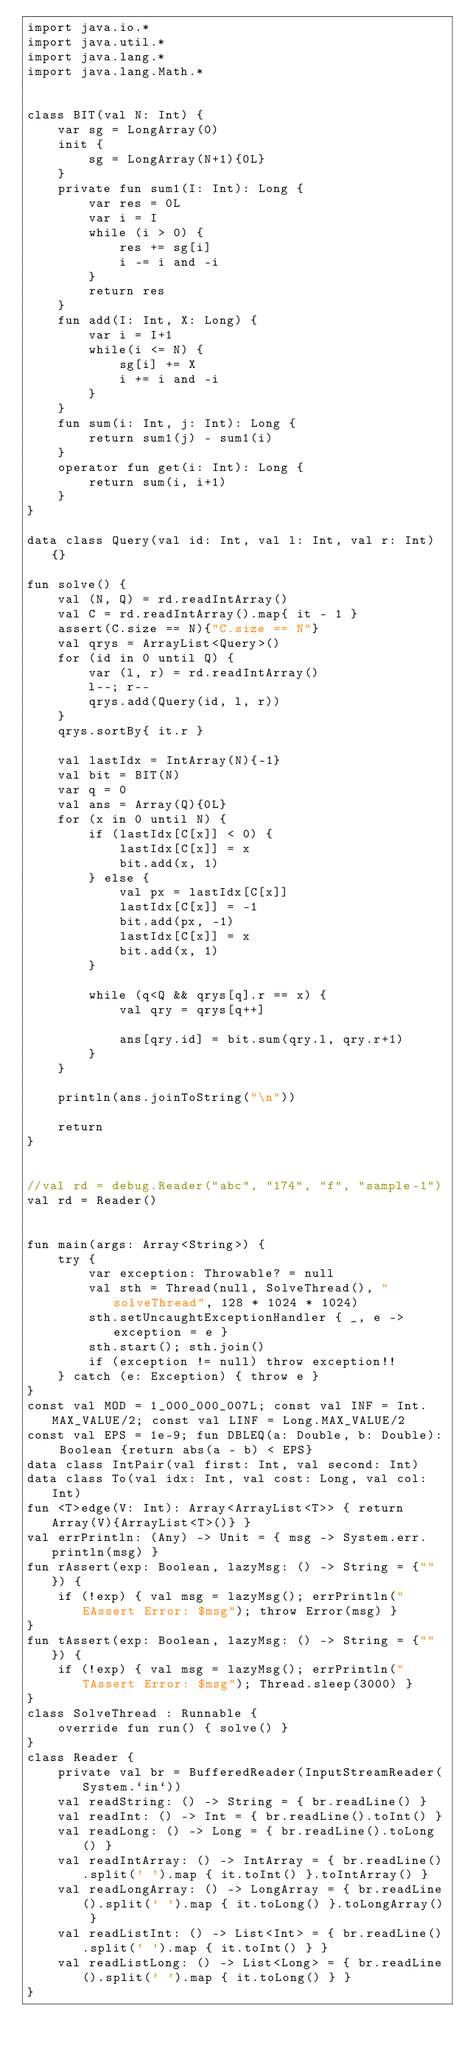<code> <loc_0><loc_0><loc_500><loc_500><_Kotlin_>import java.io.*
import java.util.*
import java.lang.*
import java.lang.Math.*


class BIT(val N: Int) {
    var sg = LongArray(0)
    init {
        sg = LongArray(N+1){0L}
    }
    private fun sum1(I: Int): Long {
        var res = 0L
        var i = I
        while (i > 0) {
            res += sg[i]
            i -= i and -i
        }
        return res
    }
    fun add(I: Int, X: Long) {
        var i = I+1
        while(i <= N) {
            sg[i] += X
            i += i and -i
        }
    }
    fun sum(i: Int, j: Int): Long {
        return sum1(j) - sum1(i)
    }
    operator fun get(i: Int): Long {
        return sum(i, i+1)
    }
}

data class Query(val id: Int, val l: Int, val r: Int) {}

fun solve() {
    val (N, Q) = rd.readIntArray()
    val C = rd.readIntArray().map{ it - 1 }
    assert(C.size == N){"C.size == N"}
    val qrys = ArrayList<Query>()
    for (id in 0 until Q) {
        var (l, r) = rd.readIntArray()
        l--; r--
        qrys.add(Query(id, l, r))
    }
    qrys.sortBy{ it.r }

    val lastIdx = IntArray(N){-1}
    val bit = BIT(N)
    var q = 0
    val ans = Array(Q){0L}
    for (x in 0 until N) {
        if (lastIdx[C[x]] < 0) {
            lastIdx[C[x]] = x
            bit.add(x, 1)
        } else {
            val px = lastIdx[C[x]]
            lastIdx[C[x]] = -1
            bit.add(px, -1)
            lastIdx[C[x]] = x
            bit.add(x, 1)
        }

        while (q<Q && qrys[q].r == x) {
            val qry = qrys[q++]

            ans[qry.id] = bit.sum(qry.l, qry.r+1)
        }
    }

    println(ans.joinToString("\n"))

    return
}


//val rd = debug.Reader("abc", "174", "f", "sample-1")
val rd = Reader()


fun main(args: Array<String>) {
    try {
        var exception: Throwable? = null
        val sth = Thread(null, SolveThread(), "solveThread", 128 * 1024 * 1024)
        sth.setUncaughtExceptionHandler { _, e -> exception = e }
        sth.start(); sth.join()
        if (exception != null) throw exception!!
    } catch (e: Exception) { throw e }
}
const val MOD = 1_000_000_007L; const val INF = Int.MAX_VALUE/2; const val LINF = Long.MAX_VALUE/2
const val EPS = 1e-9; fun DBLEQ(a: Double, b: Double): Boolean {return abs(a - b) < EPS}
data class IntPair(val first: Int, val second: Int)
data class To(val idx: Int, val cost: Long, val col: Int)
fun <T>edge(V: Int): Array<ArrayList<T>> { return Array(V){ArrayList<T>()} }
val errPrintln: (Any) -> Unit = { msg -> System.err.println(msg) }
fun rAssert(exp: Boolean, lazyMsg: () -> String = {""}) {
    if (!exp) { val msg = lazyMsg(); errPrintln("EAssert Error: $msg"); throw Error(msg) }
}
fun tAssert(exp: Boolean, lazyMsg: () -> String = {""}) {
    if (!exp) { val msg = lazyMsg(); errPrintln("TAssert Error: $msg"); Thread.sleep(3000) }
}
class SolveThread : Runnable {
    override fun run() { solve() }
}
class Reader {
    private val br = BufferedReader(InputStreamReader(System.`in`))
    val readString: () -> String = { br.readLine() }
    val readInt: () -> Int = { br.readLine().toInt() }
    val readLong: () -> Long = { br.readLine().toLong() }
    val readIntArray: () -> IntArray = { br.readLine().split(' ').map { it.toInt() }.toIntArray() }
    val readLongArray: () -> LongArray = { br.readLine().split(' ').map { it.toLong() }.toLongArray() }
    val readListInt: () -> List<Int> = { br.readLine().split(' ').map { it.toInt() } }
    val readListLong: () -> List<Long> = { br.readLine().split(' ').map { it.toLong() } }
}
</code> 